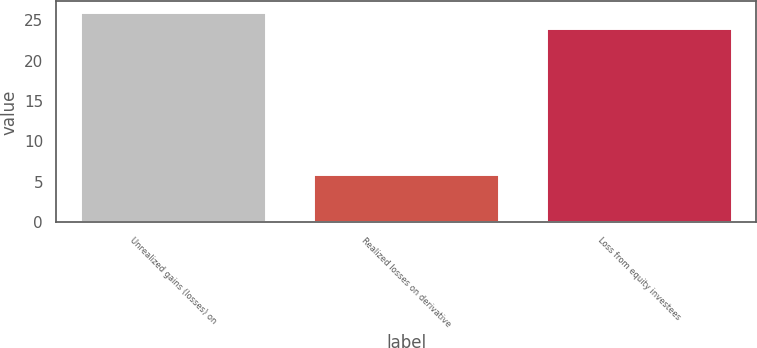Convert chart. <chart><loc_0><loc_0><loc_500><loc_500><bar_chart><fcel>Unrealized gains (losses) on<fcel>Realized losses on derivative<fcel>Loss from equity investees<nl><fcel>26<fcel>6<fcel>24<nl></chart> 